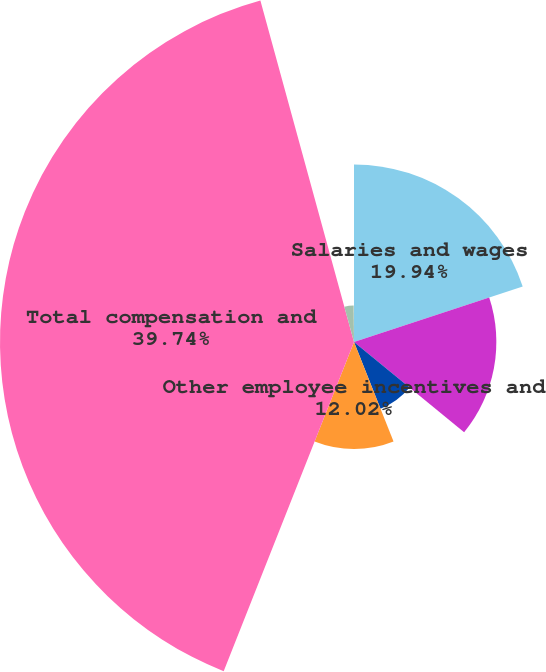Convert chart. <chart><loc_0><loc_0><loc_500><loc_500><pie_chart><fcel>Salaries and wages<fcel>Incentive compensation<fcel>ESOP<fcel>Other employee incentives and<fcel>Total compensation and<fcel>Period-end full-time<fcel>Average full-time equivalent<nl><fcel>19.94%<fcel>15.98%<fcel>8.06%<fcel>12.02%<fcel>39.74%<fcel>4.11%<fcel>0.15%<nl></chart> 